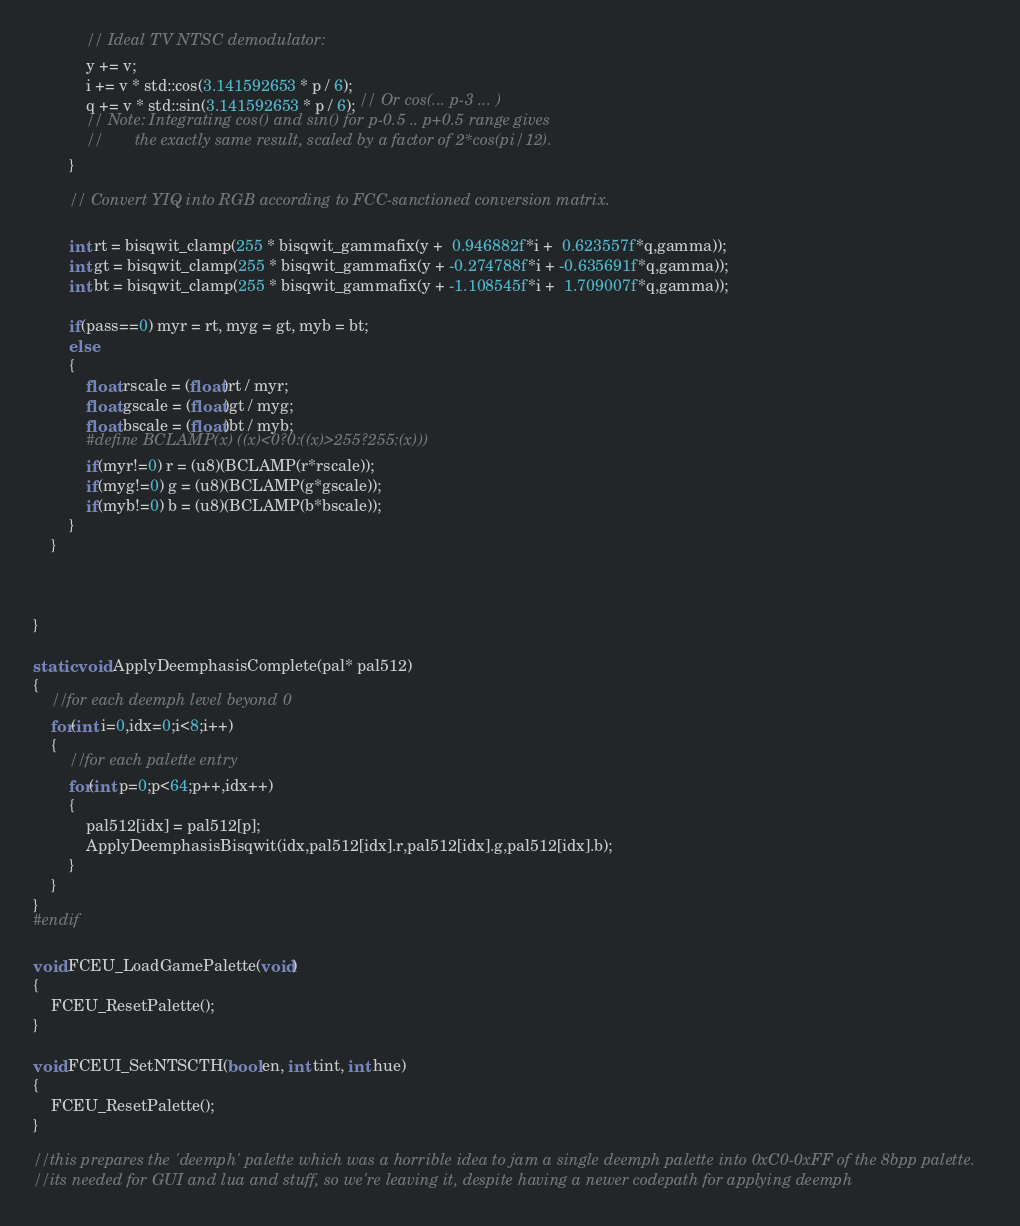Convert code to text. <code><loc_0><loc_0><loc_500><loc_500><_C++_>			// Ideal TV NTSC demodulator:
			y += v;
			i += v * std::cos(3.141592653 * p / 6);
			q += v * std::sin(3.141592653 * p / 6); // Or cos(... p-3 ... )
			// Note: Integrating cos() and sin() for p-0.5 .. p+0.5 range gives
			//       the exactly same result, scaled by a factor of 2*cos(pi/12).
		}

		// Convert YIQ into RGB according to FCC-sanctioned conversion matrix.

		int rt = bisqwit_clamp(255 * bisqwit_gammafix(y +  0.946882f*i +  0.623557f*q,gamma));
		int gt = bisqwit_clamp(255 * bisqwit_gammafix(y + -0.274788f*i + -0.635691f*q,gamma));
		int bt = bisqwit_clamp(255 * bisqwit_gammafix(y + -1.108545f*i +  1.709007f*q,gamma));

		if(pass==0) myr = rt, myg = gt, myb = bt;
		else
		{
			float rscale = (float)rt / myr;
			float gscale = (float)gt / myg;
			float bscale = (float)bt / myb;
			#define BCLAMP(x) ((x)<0?0:((x)>255?255:(x)))
			if(myr!=0) r = (u8)(BCLAMP(r*rscale));
			if(myg!=0) g = (u8)(BCLAMP(g*gscale));
			if(myb!=0) b = (u8)(BCLAMP(b*bscale));
		}
	}



}

static void ApplyDeemphasisComplete(pal* pal512)
{
	//for each deemph level beyond 0
	for(int i=0,idx=0;i<8;i++)
	{
		//for each palette entry
		for(int p=0;p<64;p++,idx++)
		{
			pal512[idx] = pal512[p];
			ApplyDeemphasisBisqwit(idx,pal512[idx].r,pal512[idx].g,pal512[idx].b);
		}
	}
}
#endif

void FCEU_LoadGamePalette(void)
{
	FCEU_ResetPalette();
}

void FCEUI_SetNTSCTH(bool en, int tint, int hue)
{
	FCEU_ResetPalette();
}

//this prepares the 'deemph' palette which was a horrible idea to jam a single deemph palette into 0xC0-0xFF of the 8bpp palette.
//its needed for GUI and lua and stuff, so we're leaving it, despite having a newer codepath for applying deemph</code> 